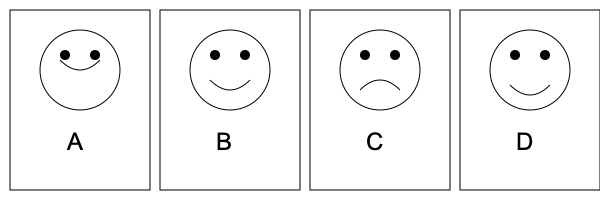As a comedian working on a new sketch with Mace & Burton, you're developing a comic strip that shows a character's reaction to a gradually worsening joke. Arrange the facial expressions A, B, C, and D in the correct sequence to show the progression from slight amusement to complete disappointment. To arrange the facial expressions in the correct sequence, we need to analyze each panel and determine the emotional progression:

1. Panel A: This shows a slight smile, indicating mild amusement or a neutral starting point.

2. Panel B: The smile has widened, suggesting increased amusement or anticipation of a good punchline.

3. Panel D: The smile has started to drop, with the corners of the mouth turning slightly downward. This indicates the character is beginning to realize the joke isn't as funny as expected.

4. Panel C: The mouth is now clearly frowning, showing complete disappointment or dissatisfaction with the joke's outcome.

The progression from slight amusement to complete disappointment follows the logical sequence of emotions a person might experience when hearing a joke that starts promisingly but fails to deliver a satisfying punchline. This sequence mirrors the common structure of comedy sketches, where the buildup and subsequent letdown are key elements of humor.

Therefore, the correct sequence of facial expressions is: A → B → D → C.
Answer: A, B, D, C 